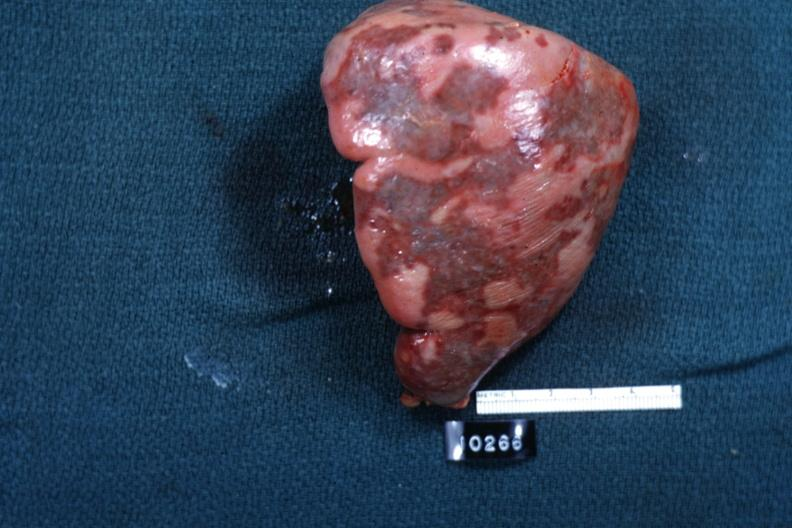where is this part in?
Answer the question using a single word or phrase. Spleen 